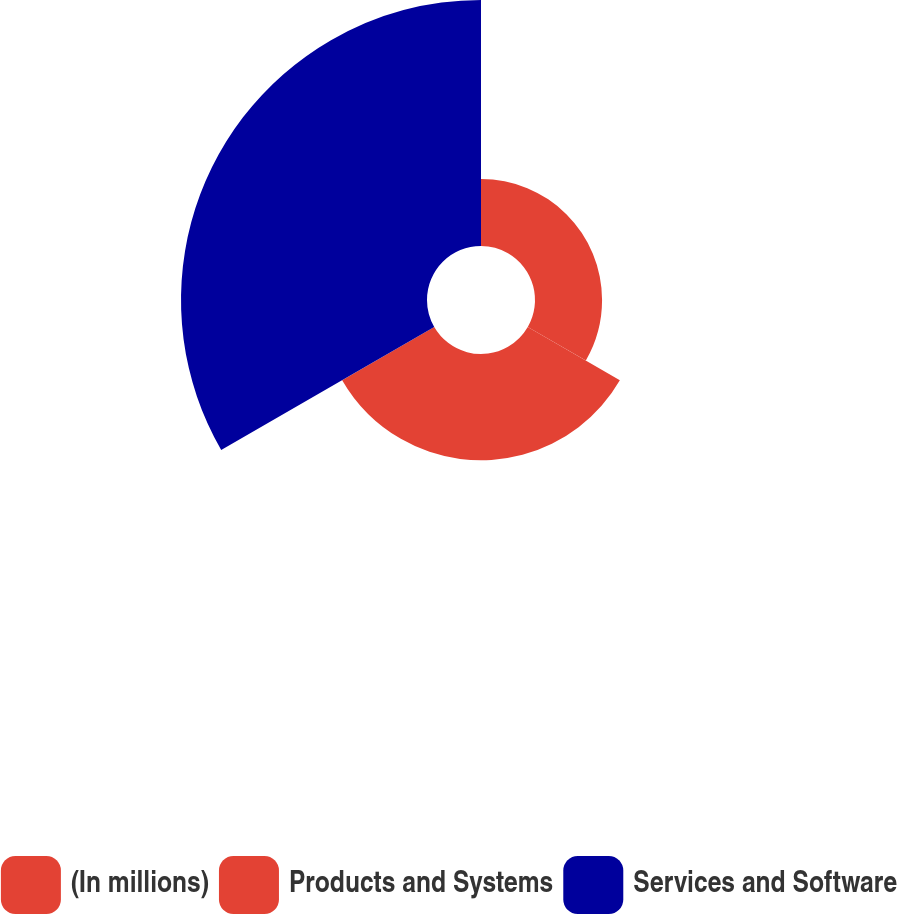<chart> <loc_0><loc_0><loc_500><loc_500><pie_chart><fcel>(In millions)<fcel>Products and Systems<fcel>Services and Software<nl><fcel>15.99%<fcel>25.35%<fcel>58.65%<nl></chart> 